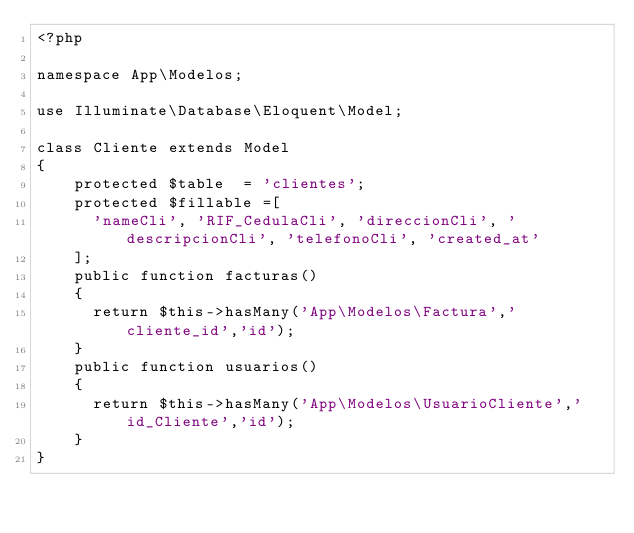Convert code to text. <code><loc_0><loc_0><loc_500><loc_500><_PHP_><?php

namespace App\Modelos;

use Illuminate\Database\Eloquent\Model;

class Cliente extends Model
{
    protected $table 	= 'clientes';
    protected $fillable	=[
    	'nameCli', 'RIF_CedulaCli', 'direccionCli', 'descripcionCli', 'telefonoCli', 'created_at'
    ];
    public function facturas()
    {
    	return $this->hasMany('App\Modelos\Factura','cliente_id','id');
    }
    public function usuarios()
    {
    	return $this->hasMany('App\Modelos\UsuarioCliente','id_Cliente','id');
    }
}
</code> 